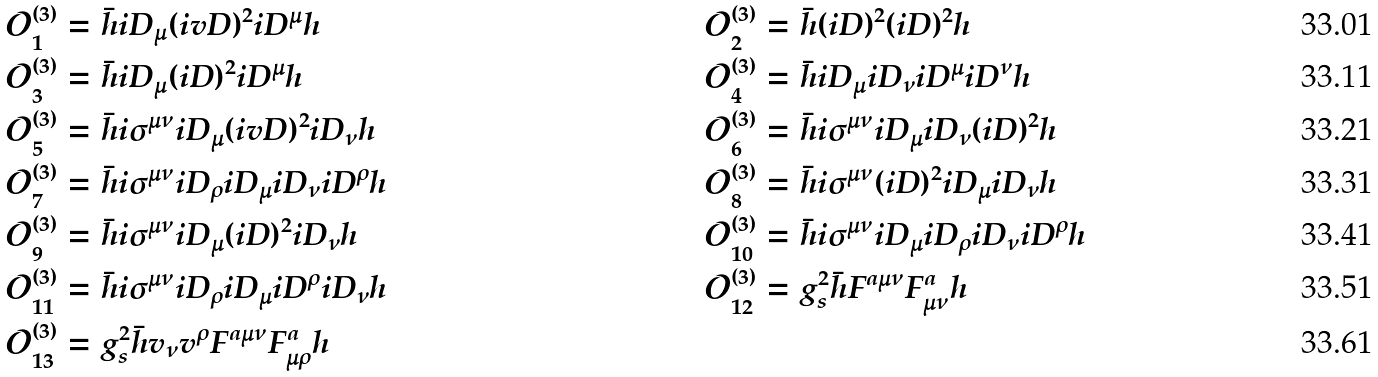<formula> <loc_0><loc_0><loc_500><loc_500>\mathcal { O } ^ { ( 3 ) } _ { 1 } & = \bar { h } i D _ { \mu } ( i v D ) ^ { 2 } i D ^ { \mu } h & \quad \mathcal { O } ^ { ( 3 ) } _ { 2 } & = \bar { h } ( i D ) ^ { 2 } ( i D ) ^ { 2 } h \\ \mathcal { O } ^ { ( 3 ) } _ { 3 } & = \bar { h } i D _ { \mu } ( i D ) ^ { 2 } i D ^ { \mu } h & \quad \mathcal { O } ^ { ( 3 ) } _ { 4 } & = \bar { h } i D _ { \mu } i D _ { \nu } i D ^ { \mu } i D ^ { \nu } h \\ \mathcal { O } ^ { ( 3 ) } _ { 5 } & = \bar { h } i \sigma ^ { \mu \nu } i D _ { \mu } ( i v D ) ^ { 2 } i D _ { \nu } h & \quad \mathcal { O } ^ { ( 3 ) } _ { 6 } & = \bar { h } i \sigma ^ { \mu \nu } i D _ { \mu } i D _ { \nu } ( i D ) ^ { 2 } h \\ \mathcal { O } ^ { ( 3 ) } _ { 7 } & = \bar { h } i \sigma ^ { \mu \nu } i D _ { \rho } i D _ { \mu } i D _ { \nu } i D ^ { \rho } h & \quad \mathcal { O } ^ { ( 3 ) } _ { 8 } & = \bar { h } i \sigma ^ { \mu \nu } ( i D ) ^ { 2 } i D _ { \mu } i D _ { \nu } h \\ \mathcal { O } ^ { ( 3 ) } _ { 9 } & = \bar { h } i \sigma ^ { \mu \nu } i D _ { \mu } ( i D ) ^ { 2 } i D _ { \nu } h & \quad \mathcal { O } ^ { ( 3 ) } _ { 1 0 } & = \bar { h } i \sigma ^ { \mu \nu } i D _ { \mu } i D _ { \rho } i D _ { \nu } i D ^ { \rho } h \\ \mathcal { O } ^ { ( 3 ) } _ { 1 1 } & = \bar { h } i \sigma ^ { \mu \nu } i D _ { \rho } i D _ { \mu } i D ^ { \rho } i D _ { \nu } h & \quad \mathcal { O } ^ { ( 3 ) } _ { 1 2 } & = g _ { s } ^ { 2 } \bar { h } F ^ { a \mu \nu } F ^ { a } _ { \mu \nu } h \\ \mathcal { O } ^ { ( 3 ) } _ { 1 3 } & = g _ { s } ^ { 2 } \bar { h } v _ { \nu } v ^ { \rho } F ^ { a \mu \nu } F ^ { a } _ { \mu \rho } h &</formula> 